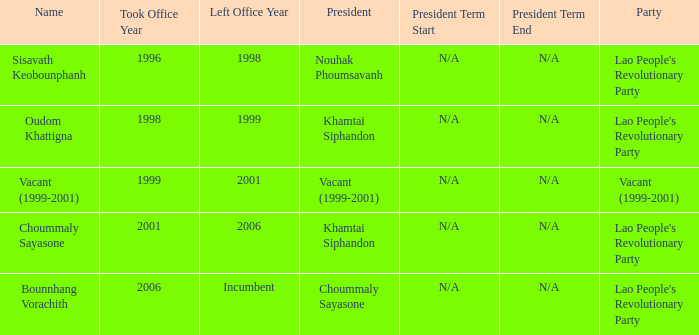What is Left Office, when Took Office is 1998? 1999.0. 